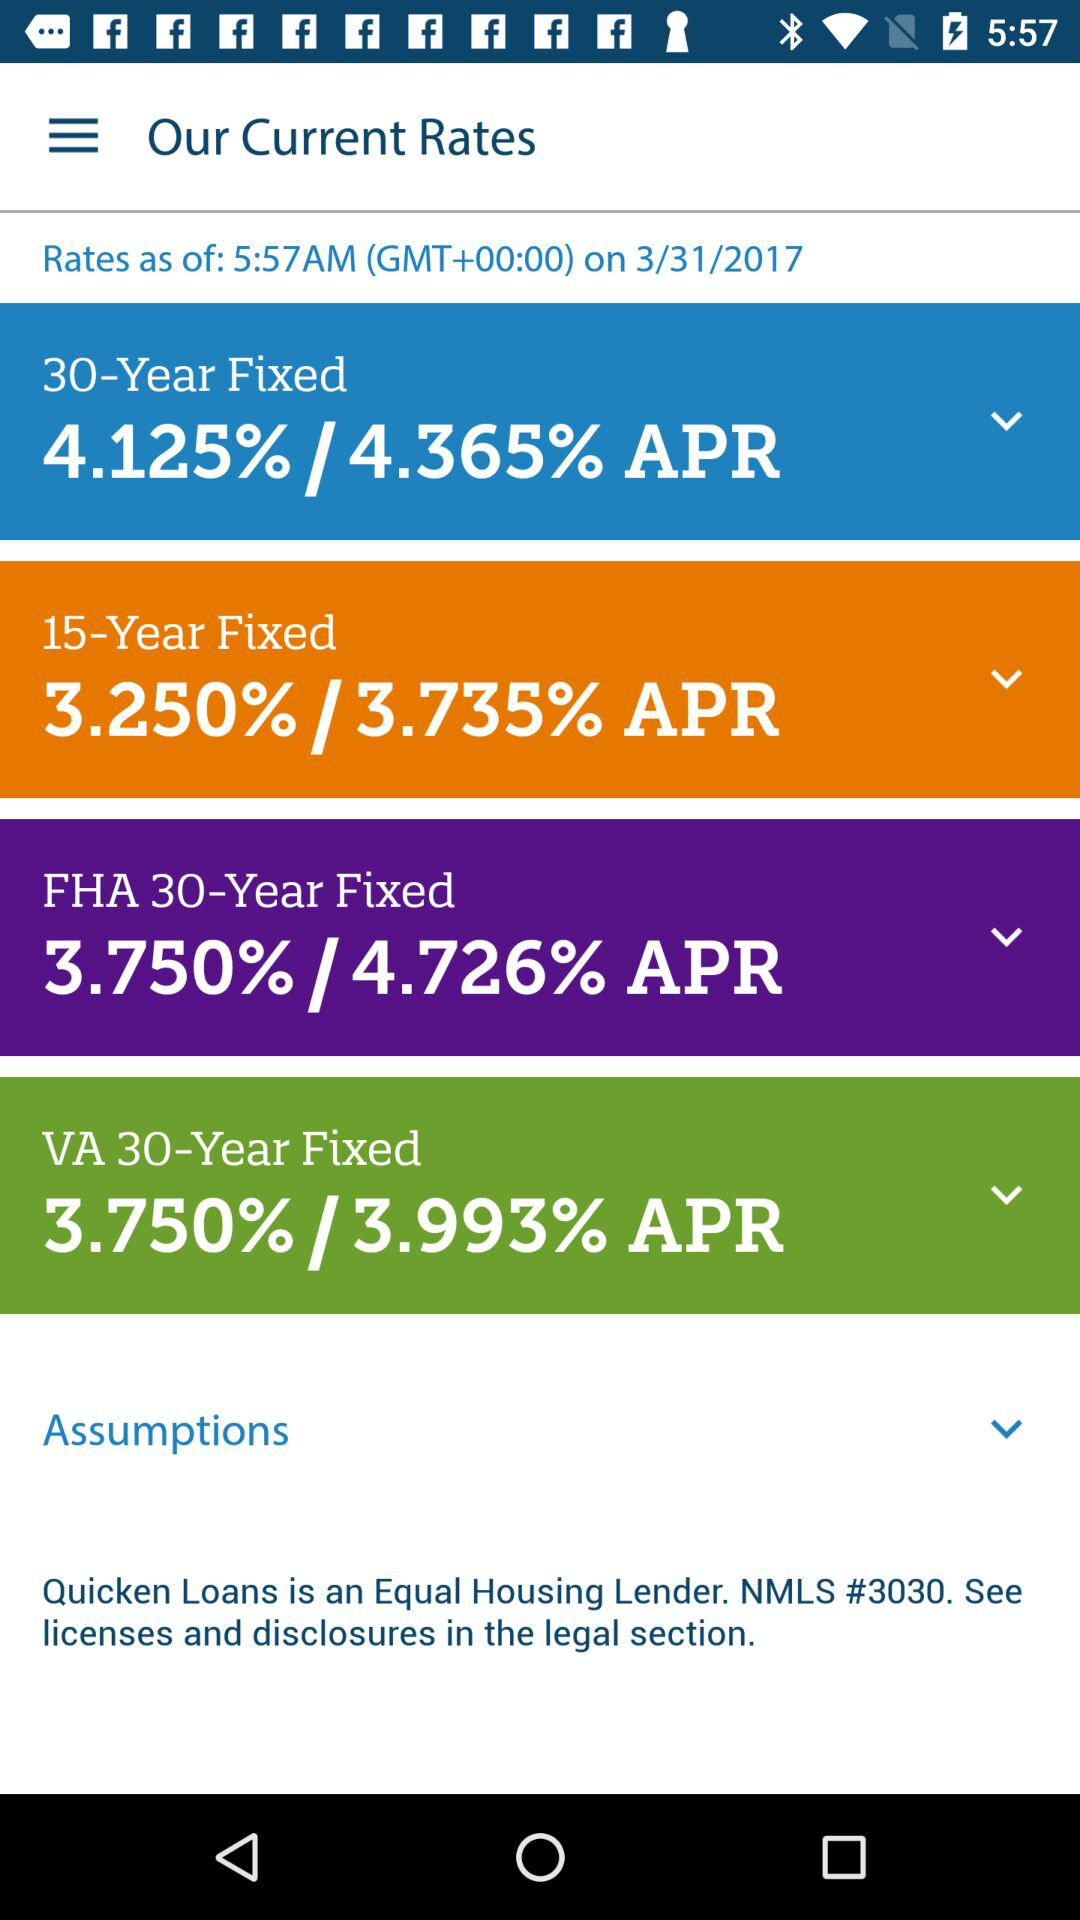How many APRs are less than 4%?
Answer the question using a single word or phrase. 2 